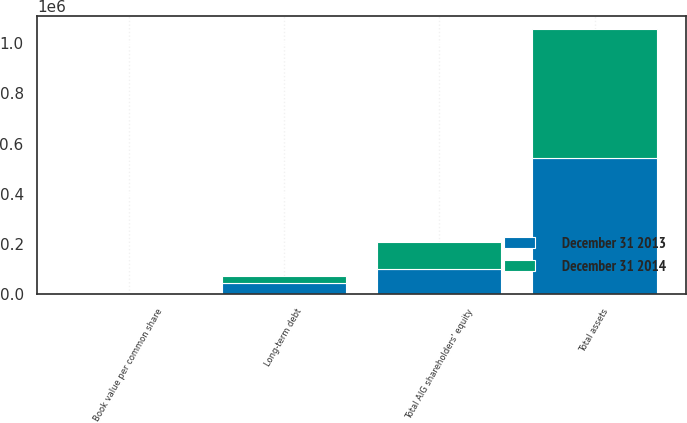Convert chart to OTSL. <chart><loc_0><loc_0><loc_500><loc_500><stacked_bar_chart><ecel><fcel>Total assets<fcel>Long-term debt<fcel>Total AIG shareholders' equity<fcel>Book value per common share<nl><fcel>December 31 2014<fcel>515581<fcel>31217<fcel>106898<fcel>69.98<nl><fcel>December 31 2013<fcel>541329<fcel>41693<fcel>100470<fcel>64.28<nl></chart> 